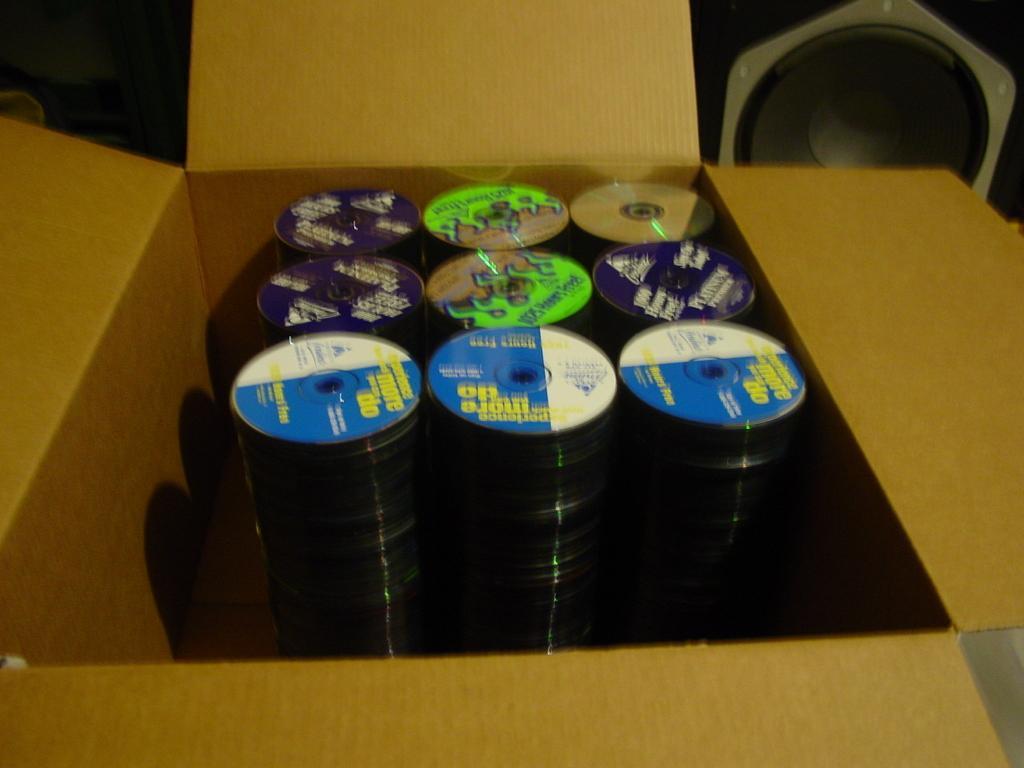Please provide a concise description of this image. In this picture we can see some Cd's are placed in a box. 